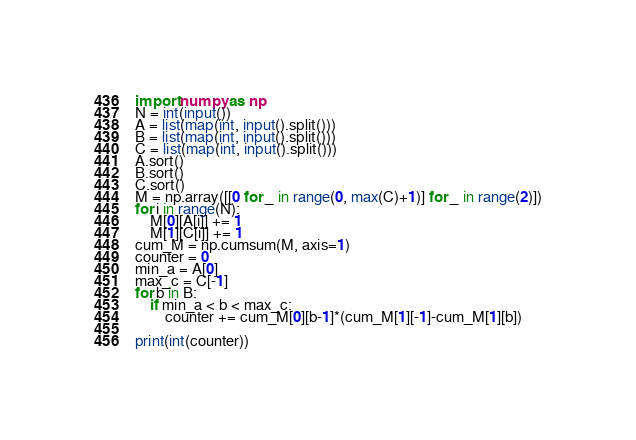<code> <loc_0><loc_0><loc_500><loc_500><_Python_>import numpy as np
N = int(input())
A = list(map(int, input().split()))
B = list(map(int, input().split()))
C = list(map(int, input().split()))
A.sort()
B.sort()
C.sort()
M = np.array([[0 for _ in range(0, max(C)+1)] for _ in range(2)])
for i in range(N):
    M[0][A[i]] += 1
    M[1][C[i]] += 1
cum_M = np.cumsum(M, axis=1)
counter = 0
min_a = A[0]
max_c = C[-1]
for b in B:
    if min_a < b < max_c:
        counter += cum_M[0][b-1]*(cum_M[1][-1]-cum_M[1][b])
        
print(int(counter))
</code> 